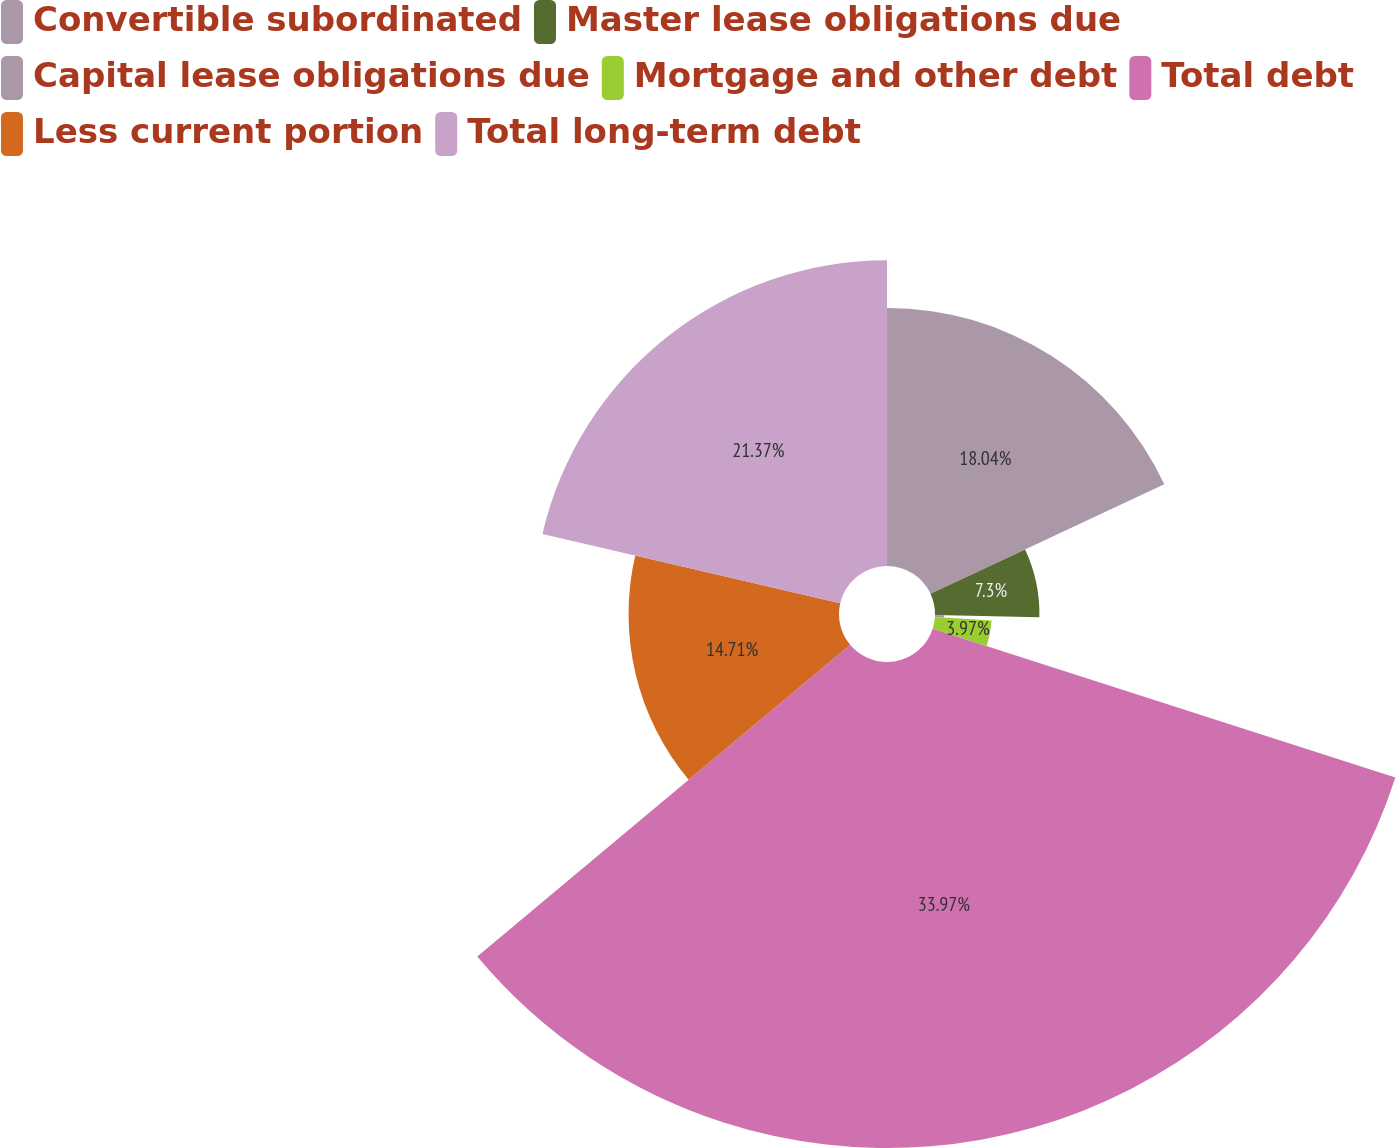Convert chart. <chart><loc_0><loc_0><loc_500><loc_500><pie_chart><fcel>Convertible subordinated<fcel>Master lease obligations due<fcel>Capital lease obligations due<fcel>Mortgage and other debt<fcel>Total debt<fcel>Less current portion<fcel>Total long-term debt<nl><fcel>18.04%<fcel>7.3%<fcel>0.64%<fcel>3.97%<fcel>33.97%<fcel>14.71%<fcel>21.37%<nl></chart> 